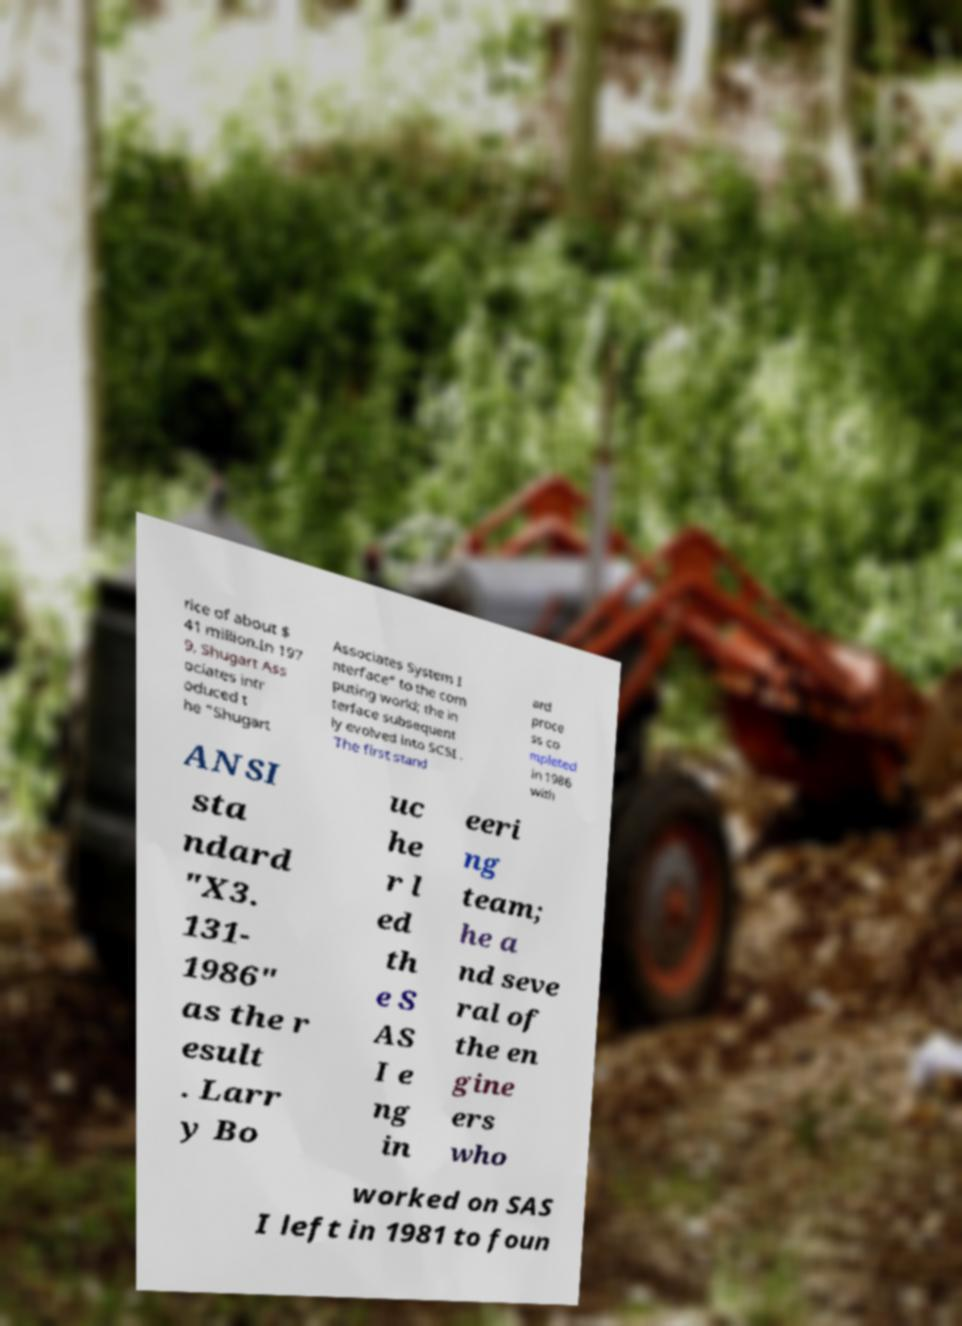Can you accurately transcribe the text from the provided image for me? rice of about $ 41 million.In 197 9, Shugart Ass ociates intr oduced t he "Shugart Associates System I nterface" to the com puting world; the in terface subsequent ly evolved into SCSI . The first stand ard proce ss co mpleted in 1986 with ANSI sta ndard "X3. 131- 1986" as the r esult . Larr y Bo uc he r l ed th e S AS I e ng in eeri ng team; he a nd seve ral of the en gine ers who worked on SAS I left in 1981 to foun 